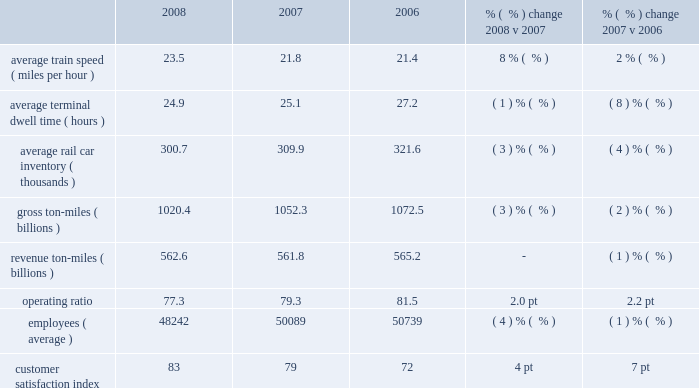Other operating/performance and financial statistics we report key railroad performance measures weekly to the association of american railroads ( aar ) , including carloads , average daily inventory of rail cars on our system , average train speed , and average terminal dwell time .
We provide this data on our website at www.up.com/investors/reports/index.shtml .
Operating/performance statistics included in the table below are railroad performance measures reported to the aar : 2008 2007 2006 % (  % ) change 2008 v 2007 % (  % ) change 2007 v 2006 .
Average train speed 2013 average train speed is calculated by dividing train miles by hours operated on our main lines between terminals .
Ongoing network management initiatives , productivity improvements , and lower volume levels contributed to 8% ( 8 % ) and 2% ( 2 % ) improvements in average train speed in 2008 and 2007 , respectively .
Average terminal dwell time 2013 average terminal dwell time is the average time that a rail car spends at our terminals .
Lower average terminal dwell time improves asset utilization and service .
Average terminal dwell time improved 1% ( 1 % ) and 8% ( 8 % ) in 2008 and 2007 , respectively .
Lower volumes combined with initiatives to more timely deliver rail cars to our interchange partners and customers improved dwell time in both periods .
Gross and revenue ton-miles 2013 gross ton-miles are calculated by multiplying the weight of loaded and empty freight cars by the number of miles hauled .
Revenue ton-miles are calculated by multiplying the weight of freight by the number of tariff miles .
Gross ton-miles decreased 3% ( 3 % ) , while revenue ton-miles were flat in 2008 compared to 2007 with commodity mix changes ( notably autos and coal ) explaining the variance in year over year growth between the two metrics .
In 2007 , revenue ton-miles declined 1% ( 1 % ) in relation to the 1% ( 1 % ) reduction in carloadings compared to 2006 .
Gross ton-miles decreased 2% ( 2 % ) in 2007 driven by a mix shift in freight shipments .
Operating ratio 2013 operating ratio is defined as our operating expenses as a percentage of operating revenue .
Our operating ratios improved 2.0 points to 77.3% ( 77.3 % ) in 2008 and 2.2 points to 79.3% ( 79.3 % ) in 2007 .
Price increases , fuel cost recoveries , network management initiatives , and improved productivity more than offset the impact of higher fuel prices .
Employees 2013 productivity initiatives and lower volumes reduced employee levels throughout the company in 2008 versus 2007 .
Fewer train and engine personnel due to improved network productivity and 5% ( 5 % ) lower volume drove the change while productivity initiatives within the support organizations also contributed to a lower full-time equivalent force level .
Lower employee levels in 2007 versus 2006 .
Based on the operating/performance statistics what was the average operating ratio from 2006 to 2008? 
Computations: ((77.3 + 79.3) + 81.5)
Answer: 238.1. 